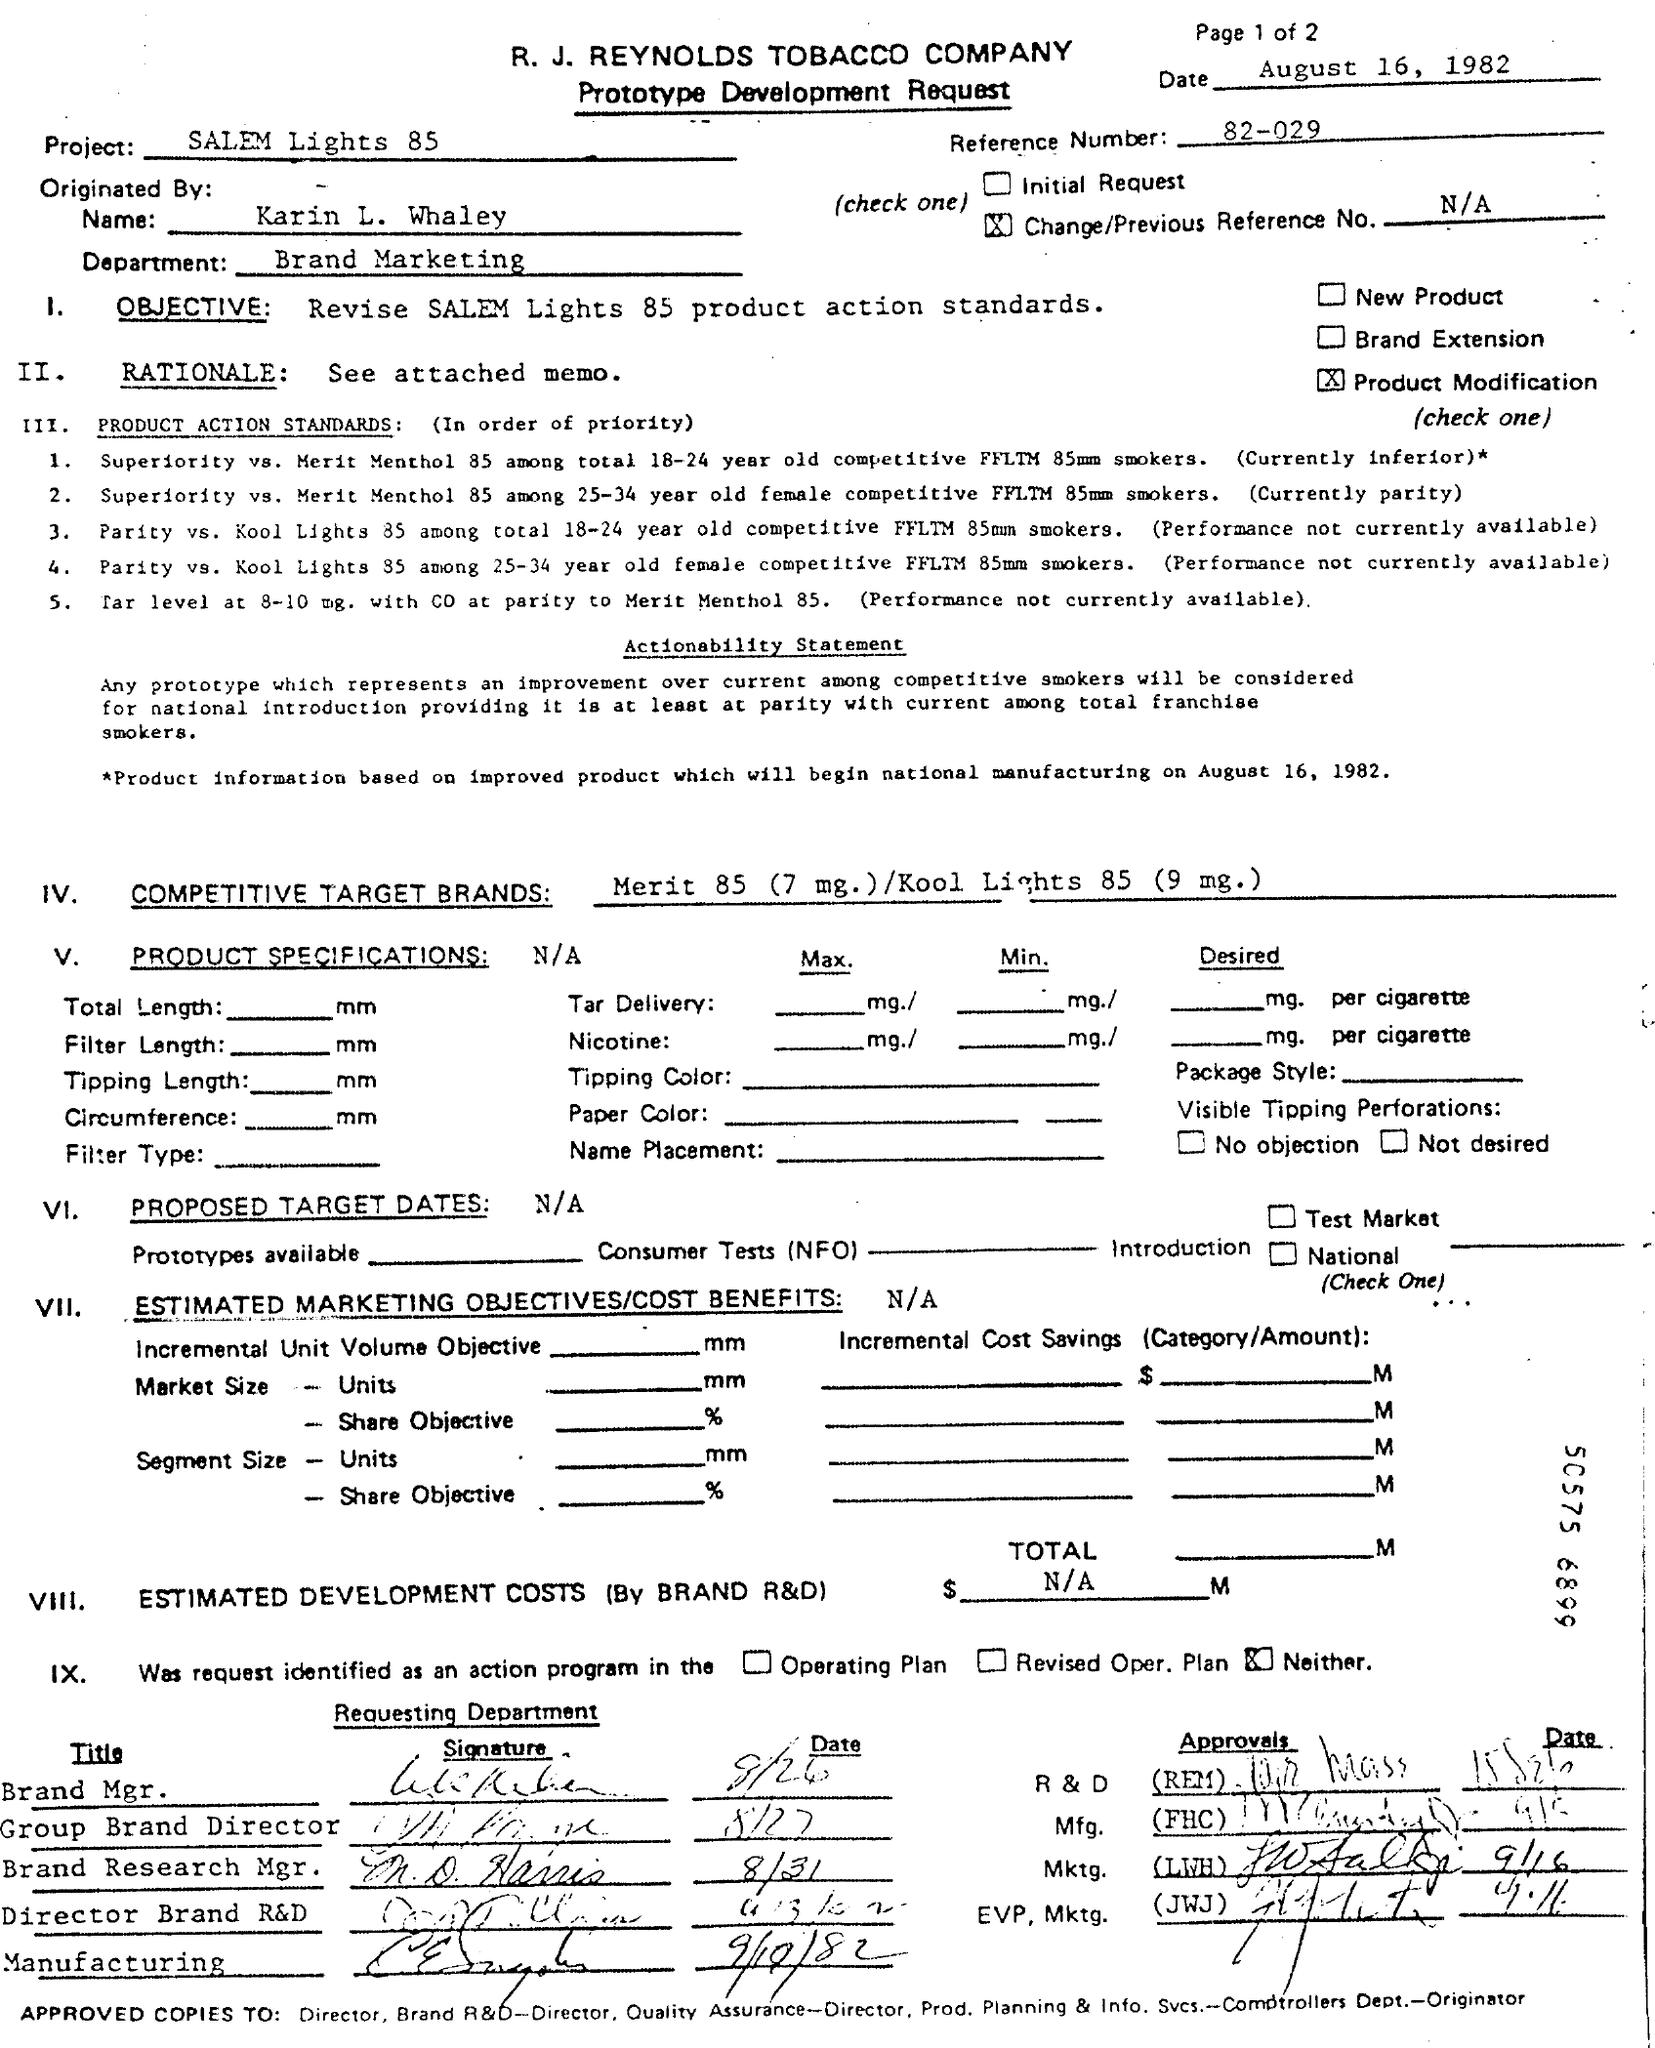List a handful of essential elements in this visual. The objective mentioned in the given document is to revise Salem Lights 85 product action standards. The name of the project mentioned in the document is "Salem Lights 85". The department mentioned in the document is brand marketing. The reference number mentioned in the document is 82-029. The document is dated August 16, 1982. 